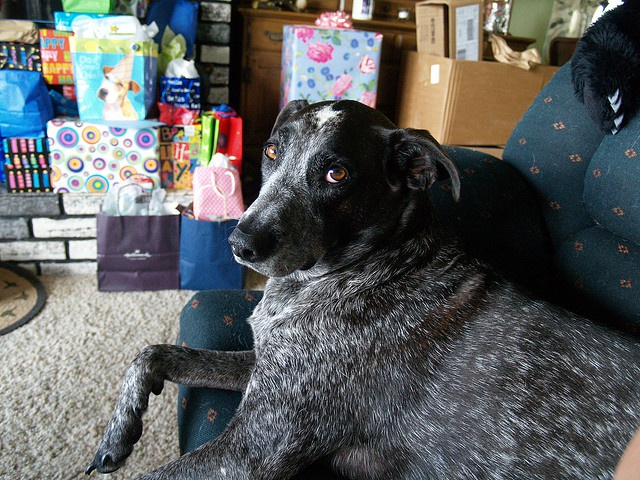Describe the objects in this image and their specific colors. I can see dog in black, gray, darkgray, and purple tones, couch in black, blue, and darkblue tones, chair in black, blue, and darkblue tones, handbag in black and purple tones, and handbag in black, blue, navy, darkblue, and gray tones in this image. 